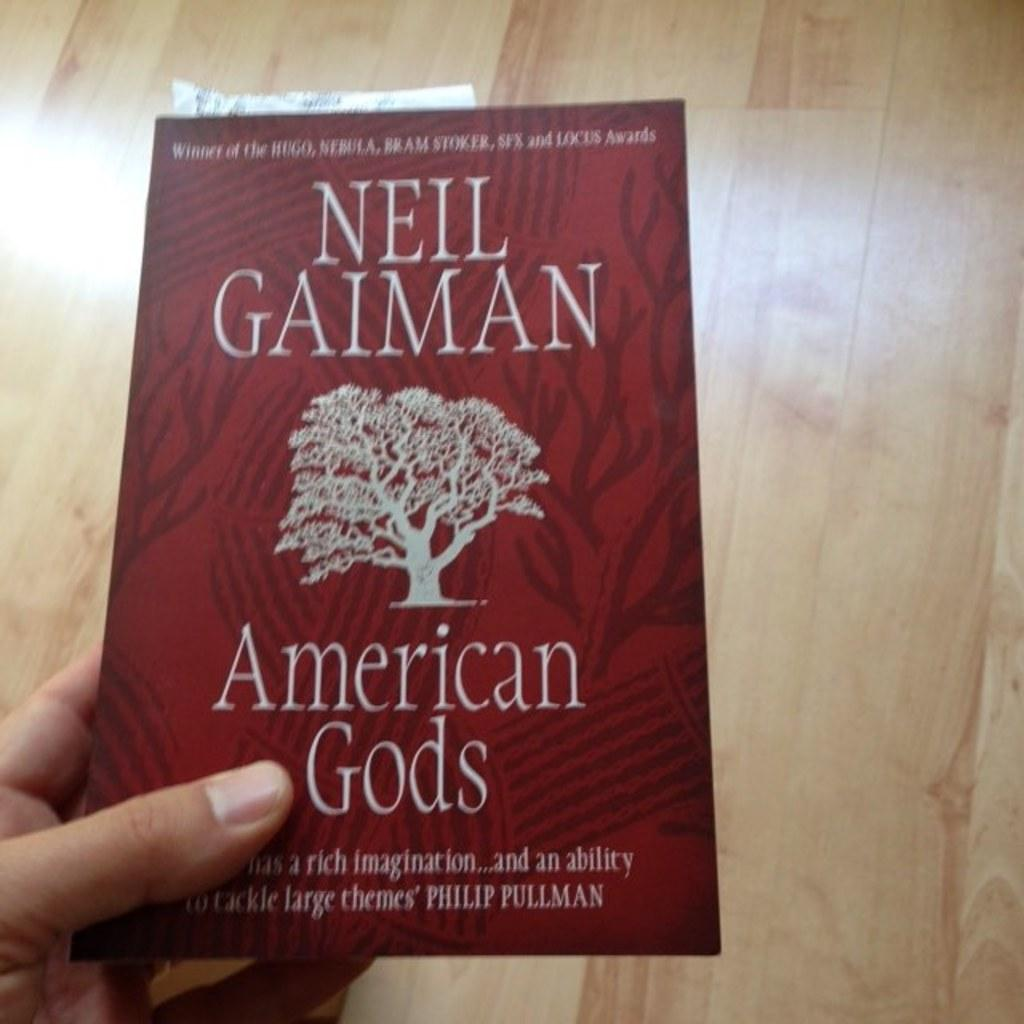<image>
Provide a brief description of the given image. The author of this book is the winner of several awards. 